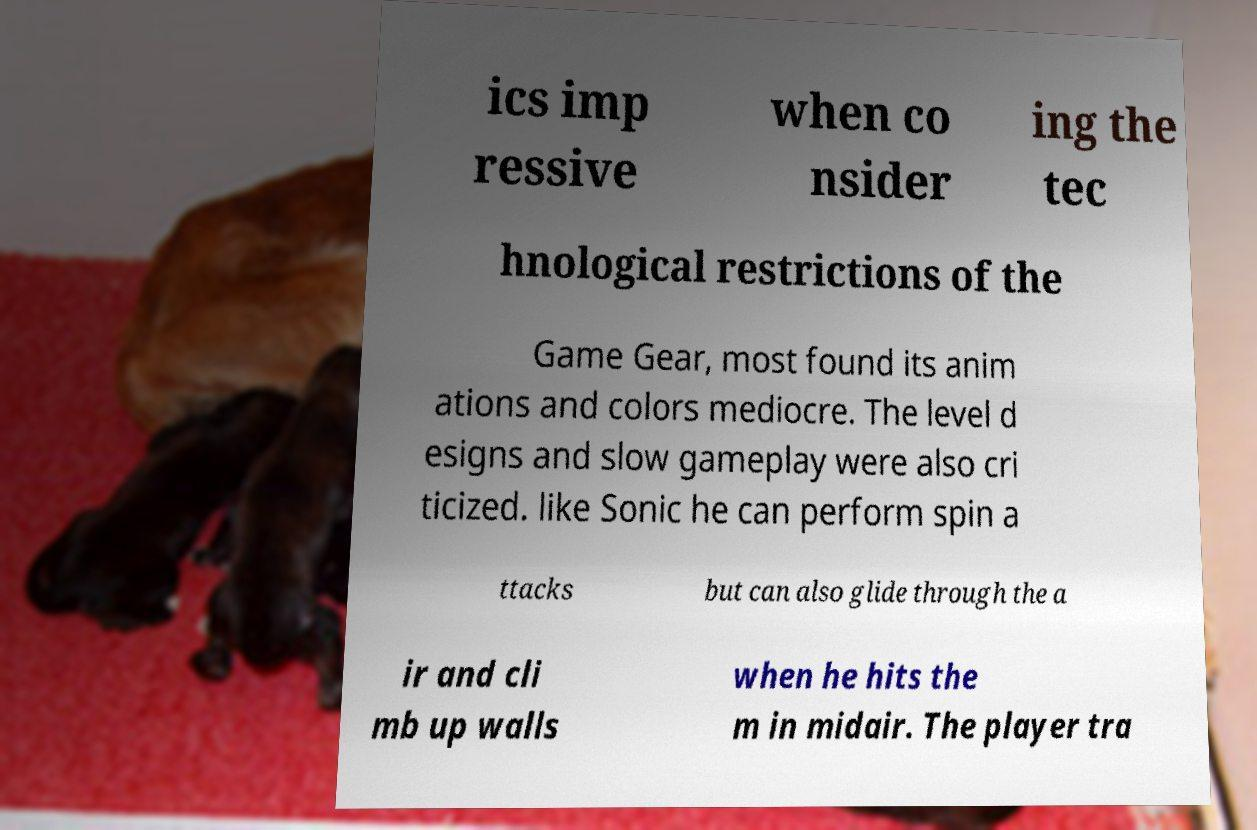For documentation purposes, I need the text within this image transcribed. Could you provide that? ics imp ressive when co nsider ing the tec hnological restrictions of the Game Gear, most found its anim ations and colors mediocre. The level d esigns and slow gameplay were also cri ticized. like Sonic he can perform spin a ttacks but can also glide through the a ir and cli mb up walls when he hits the m in midair. The player tra 